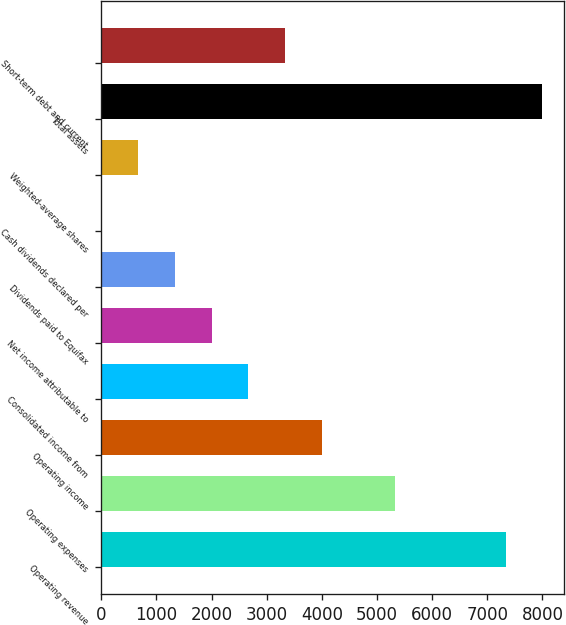Convert chart to OTSL. <chart><loc_0><loc_0><loc_500><loc_500><bar_chart><fcel>Operating revenue<fcel>Operating expenses<fcel>Operating income<fcel>Consolidated income from<fcel>Net income attributable to<fcel>Dividends paid to Equifax<fcel>Cash dividends declared per<fcel>Weighted-average shares<fcel>Total assets<fcel>Short-term debt and current<nl><fcel>7330.29<fcel>5331.48<fcel>3998.94<fcel>2666.4<fcel>2000.13<fcel>1333.86<fcel>1.32<fcel>667.59<fcel>7996.56<fcel>3332.67<nl></chart> 